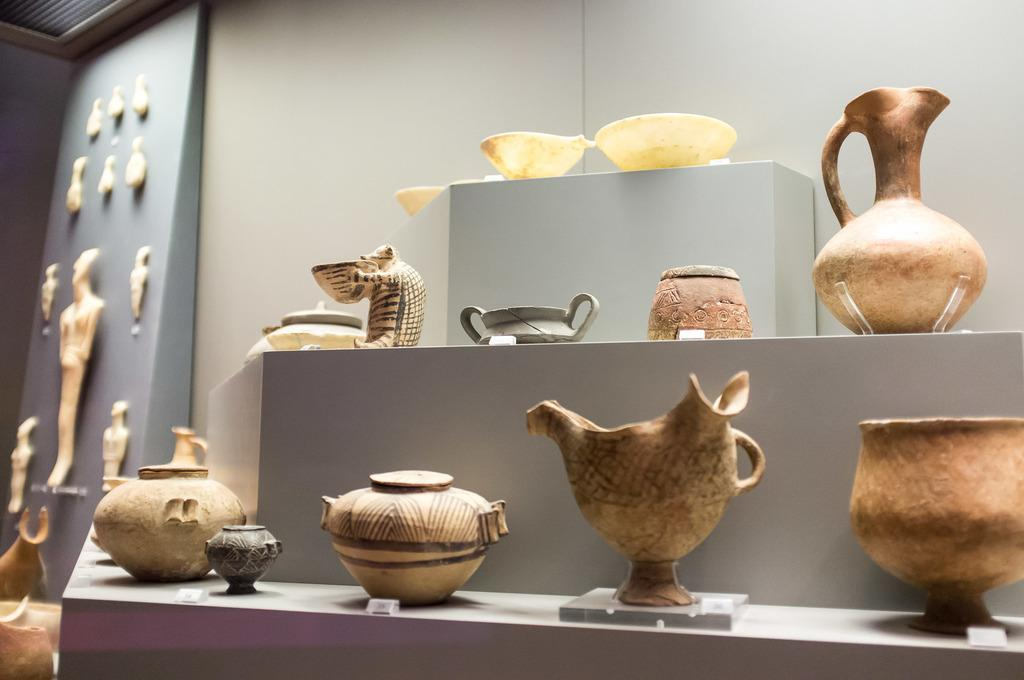What objects are on the platform in the image? There are bowls and pots on the platform in the image. Are there any other items visible on the platform? Yes, there are many other items on the platform. What can be seen in the background of the image? There is a wall in the background. What is near the wall in the image? There is a board near the wall. What is hung on the board? Many items are hanged on the board. What type of patch is sewn onto the cap in the image? There is no cap present in the image, so it is not possible to answer that question. 